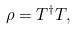<formula> <loc_0><loc_0><loc_500><loc_500>\rho = T ^ { \dagger } T ,</formula> 